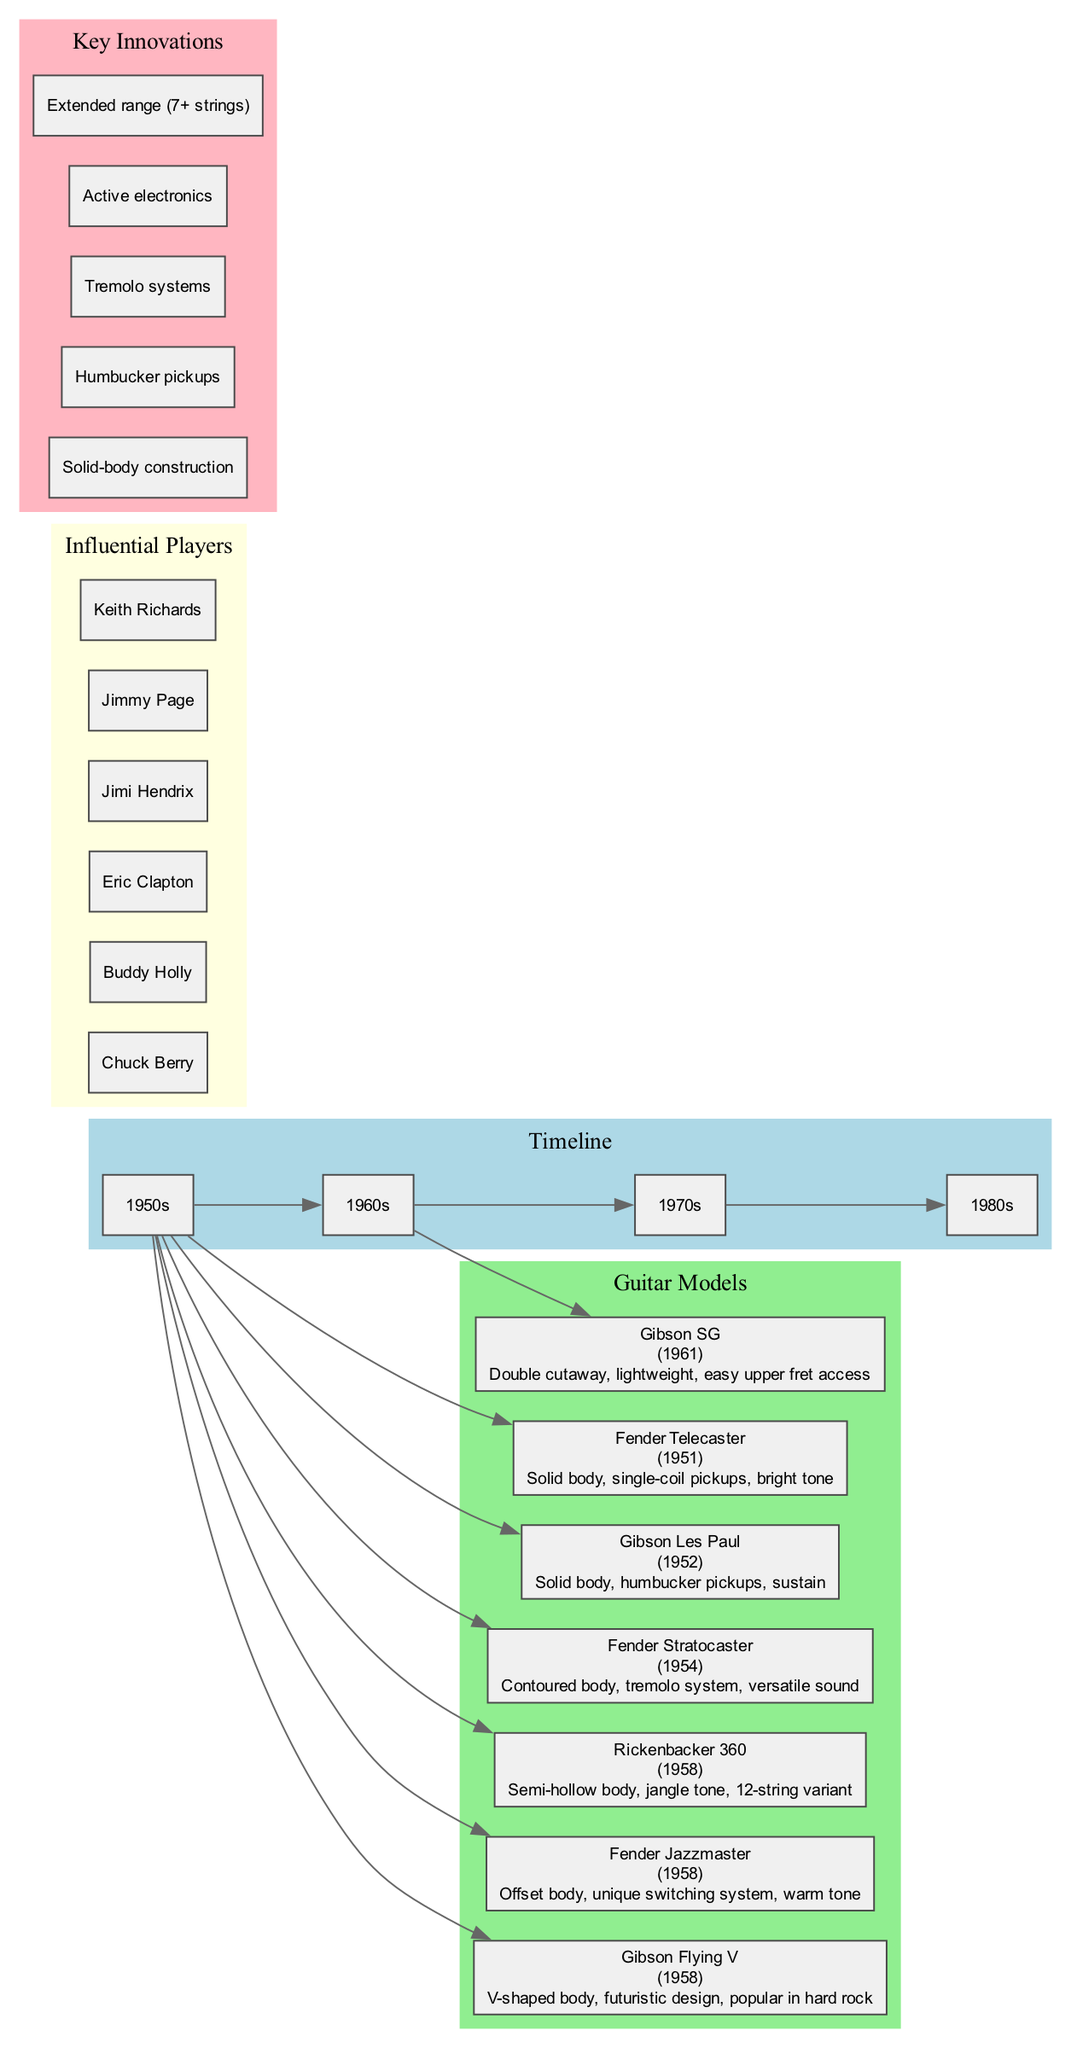What year was the Fender Telecaster introduced? The diagram displays the model Fender Telecaster under the timeline section, specifically indicating the year of introduction as 1951.
Answer: 1951 Which guitar model is characterized by a contoured body? The diagram lists the Fender Stratocaster under the guitar models and highlights its unique characteristic of having a contoured body.
Answer: Fender Stratocaster How many influential players are mentioned in the diagram? Counting the nodes in the influential players section of the diagram reveals a total of six names referenced.
Answer: 6 What key innovation is associated with solid-body construction? The key innovations section of the diagram includes "Solid-body construction" which is a listed innovation that precedes other innovations.
Answer: Solid-body construction Which guitar model features a lightweight design and easy upper fret access? The diagram shows the Gibson SG model, specifically stating "lightweight" and "easy upper fret access" as its distinguishing characteristics.
Answer: Gibson SG Which decade saw the introduction of the Gibson Flying V? By observing the timeline, the Gibson Flying V was introduced in 1958, which falls within the 1950s decade category.
Answer: 1950s What color represents key innovations in the diagram? In the diagram, the key innovations cluster is shown in light pink, distinguishing it from other sections.
Answer: Light pink How does the Fender Jazzmaster's body shape differ from standard guitars? The Fender Jazzmaster, as shown in the diagram, is highlighted for its unique offset body, distinguishing it from traditional guitar designs.
Answer: Offset body Which influential player is known for their association with the guitar model Gibson Les Paul? The diagram displays influential players and does not explicitly link them to a specific guitar model, but it’s widely recognized in music history that Jimmy Page is associated with the Gibson Les Paul.
Answer: Jimmy Page 